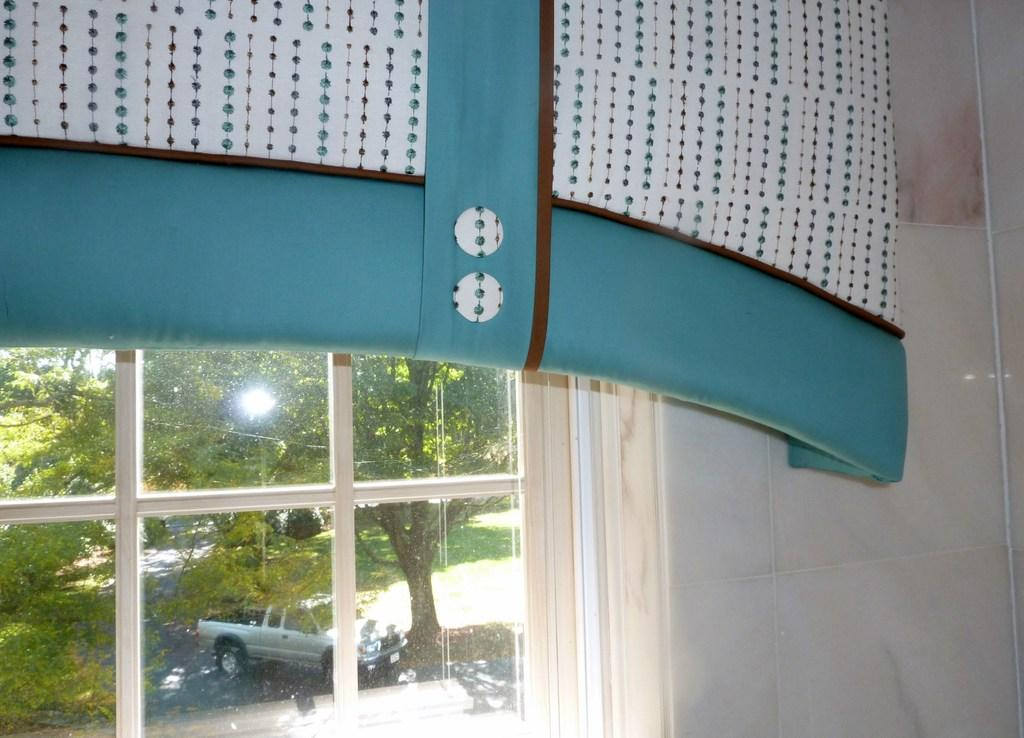What type of covering is present in the image? There is a curtain in the image. What is the primary feature of the window in the image? There is a glass window in the image. What can be seen through the glass window? Trees, vehicles, and grass are visible through the glass window. How many rings can be seen on the ant's legs in the image? There are no ants or rings present in the image. What sound does the horn make in the image? There is no horn present in the image. 